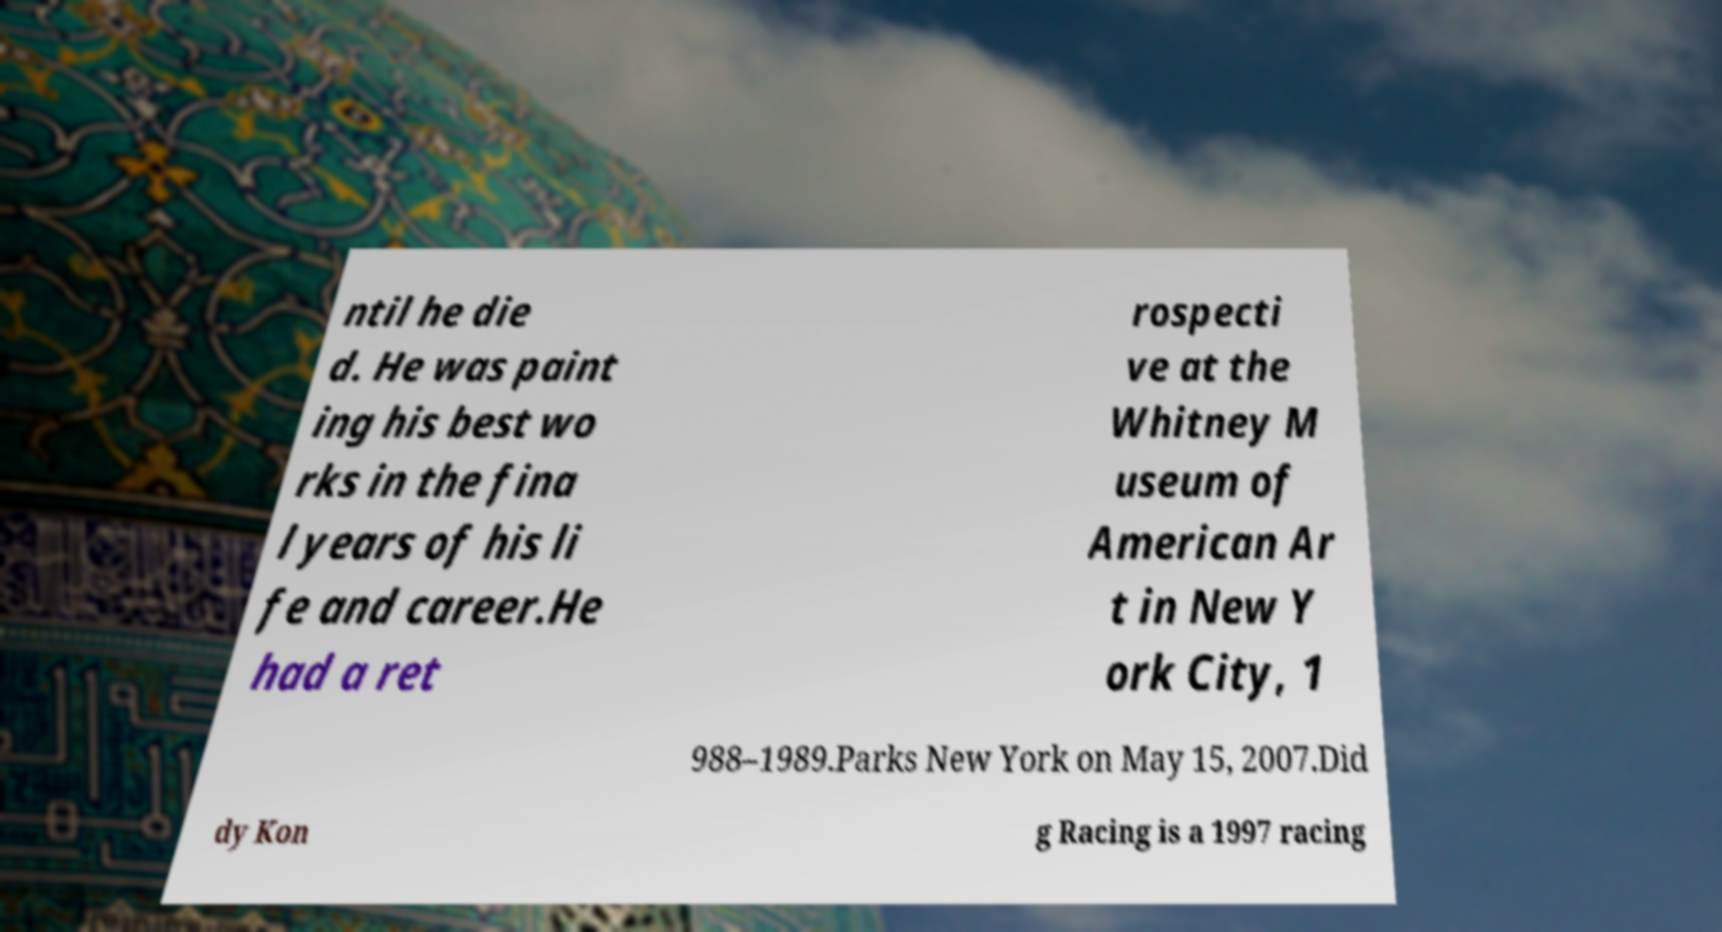Please identify and transcribe the text found in this image. ntil he die d. He was paint ing his best wo rks in the fina l years of his li fe and career.He had a ret rospecti ve at the Whitney M useum of American Ar t in New Y ork City, 1 988–1989.Parks New York on May 15, 2007.Did dy Kon g Racing is a 1997 racing 